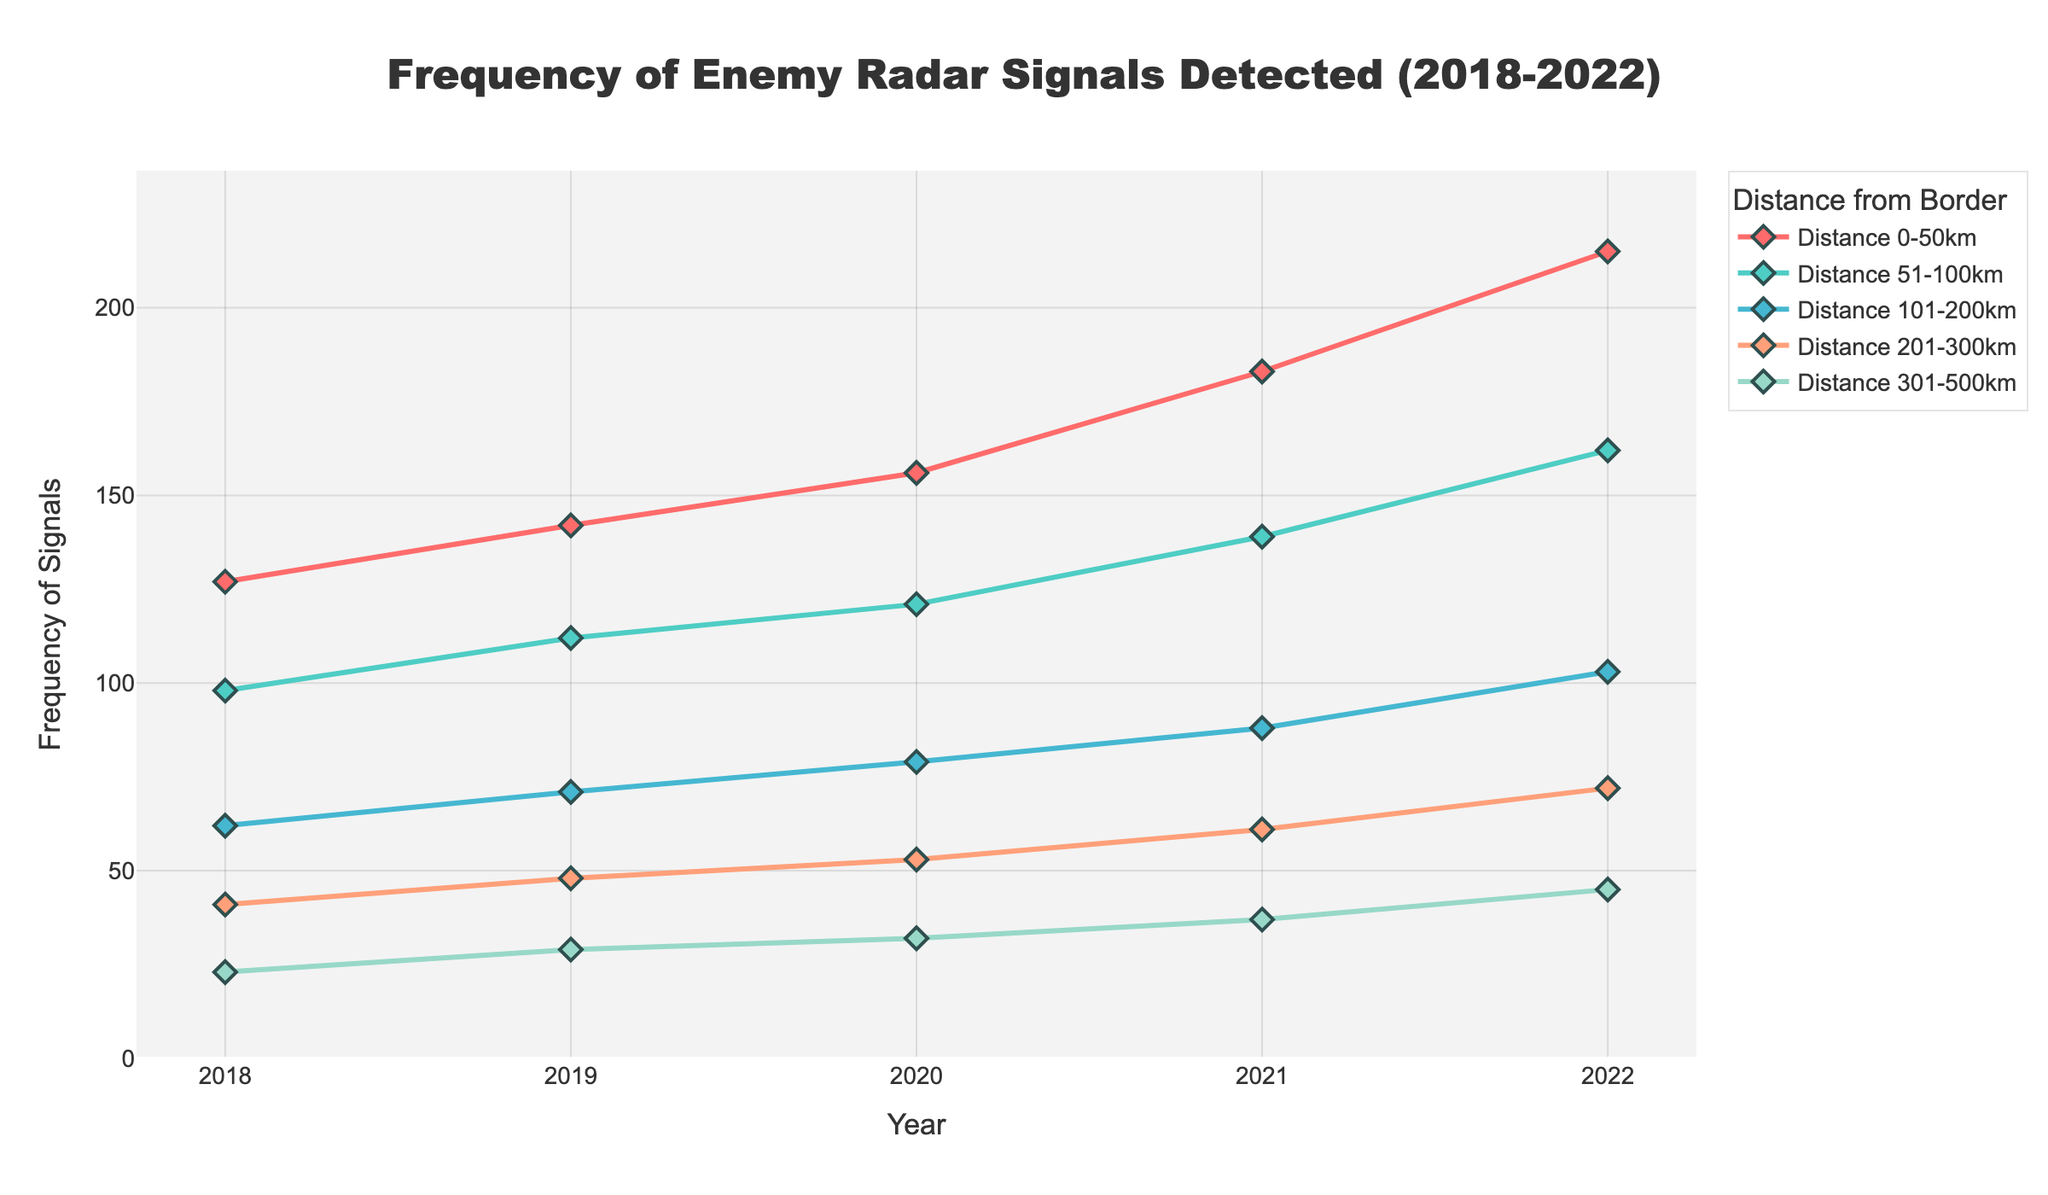What is the trend of radar signal detections at 201-300km over the 5-year period? By observing the line for "Distance 201-300km", we see a steady upward trend from 41 in 2018 to 72 in 2022.
Answer: Steady increase Which year had the highest frequency of enemy radar signals detected at 0-50km? By looking at the line for "Distance 0-50km", the highest point is at 215 in 2022.
Answer: 2022 How many more radar signals were detected at 101-200km in 2022 compared to 2018? The value for "Distance 101-200km" in 2018 is 62, and in 2022 it is 103. The difference is 103 - 62.
Answer: 41 What is the average number of radar signals detected at 51-100km over the 5 years? The values for 51-100km are 98, 112, 121, 139, 162. The sum is 632, and the average is 632/5.
Answer: 126.4 Which distance range shows the smallest increase in radar signal detection from 2018 to 2022? Calculating the increment for each distance range: 0-50km (215-127=88), 51-100km (162-98=64), 101-200km (103-62=41), 201-300km (72-41=31), 301-500km (45-23=22). The smallest increase is at 301-500km.
Answer: 301-500km In what year did the frequency of radar signals detected at 51-100km first exceed 150? By examining the line for "Distance 51-100km", it first exceeds 150 in 2022.
Answer: 2022 Which year had the greatest overall increase in radar signals across all distances from the previous year? Compare year-over-year increases: 2018-2019 (15+14+9+7+6=51), 2019-2020 (14+9+8+5+3=39), 2020-2021 (27+18+9+8+5=67), 2021-2022 (32+23+15+11+8=89). The greatest increase occurred in 2022.
Answer: 2022 How does the frequency of radar signals detected at 101-200km in 2020 compare to that at 301-500km in 2020? The value for "Distance 101-200km" in 2020 is 79, and for "Distance 301-500km" it is 32. 79 is greater than 32.
Answer: Greater What color represents the data for the 0-50km distance range? By looking at the line colors, the "Distance 0-50km" is represented by the red line.
Answer: Red What is the combined total of radar signals detected at 0-50km and 51-100km in 2021? The values are 183 for "Distance 0-50km" and 139 for "Distance 51-100km". Their sum is 183 + 139.
Answer: 322 